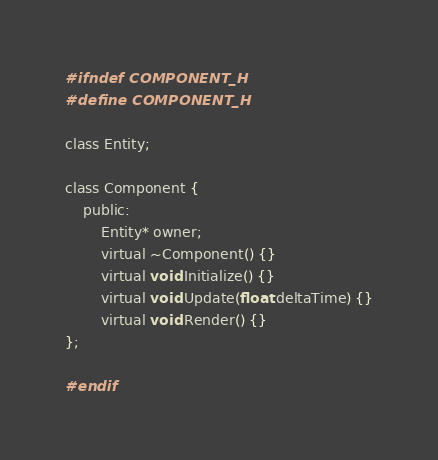<code> <loc_0><loc_0><loc_500><loc_500><_C_>#ifndef COMPONENT_H
#define COMPONENT_H

class Entity;

class Component {
    public:
        Entity* owner;
        virtual ~Component() {}
        virtual void Initialize() {}
        virtual void Update(float deltaTime) {}
        virtual void Render() {}
};

#endif
</code> 